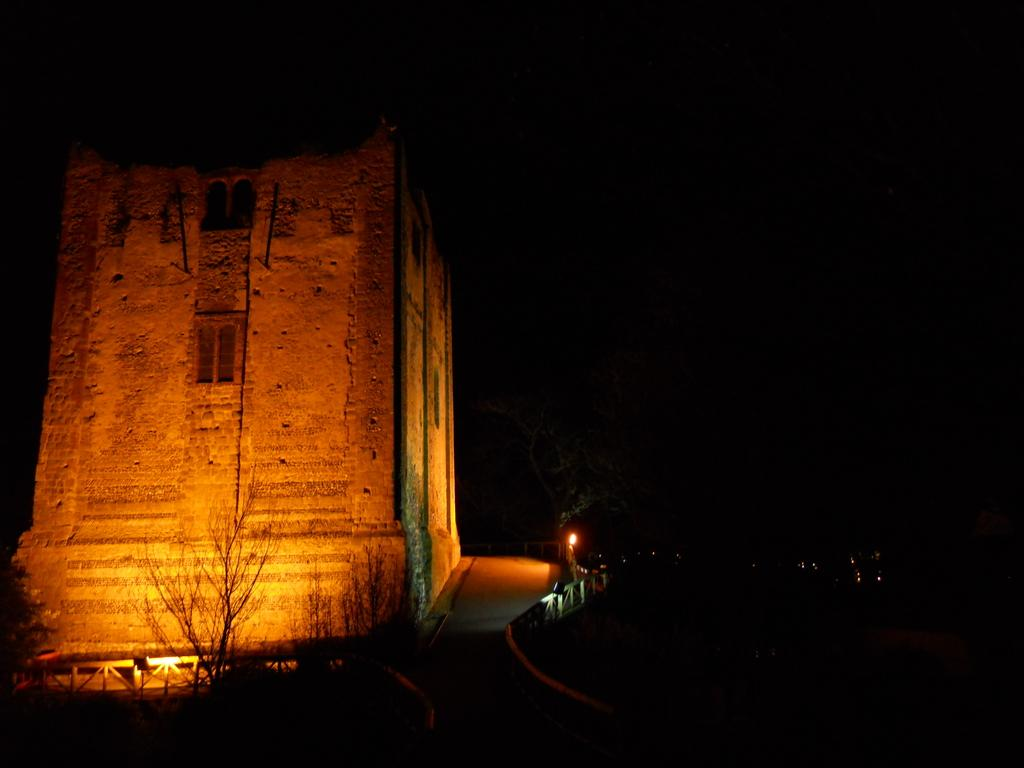What type of structure is visible in the image? There is a building in the image. What else can be seen in the image besides the building? There are lights and trees in the image. How is the tree on the left side of the image depicted? The tree on the left side of the image is truncated. What can be inferred about the lighting conditions in the scene? The background of the image is dark. What position does the self take in the image? There is no self or person present in the image. How does the image demonstrate care for the environment? The image does not demonstrate care for the environment; it simply depicts a building, lights, trees, and a truncated tree. 